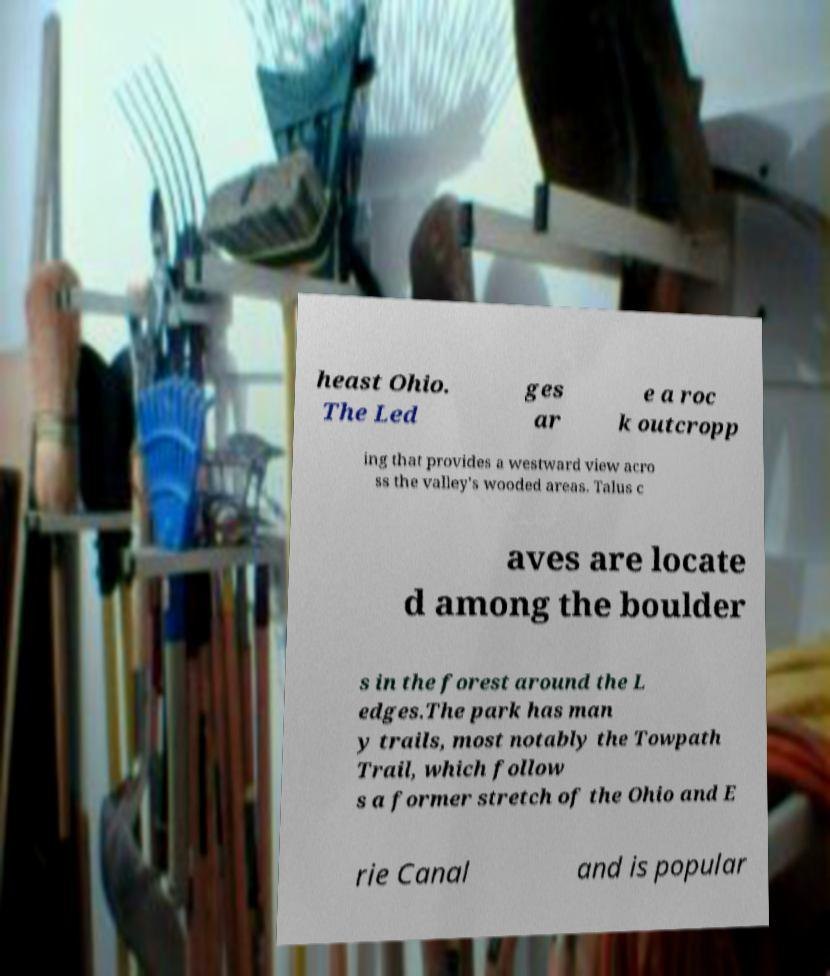Could you extract and type out the text from this image? heast Ohio. The Led ges ar e a roc k outcropp ing that provides a westward view acro ss the valley's wooded areas. Talus c aves are locate d among the boulder s in the forest around the L edges.The park has man y trails, most notably the Towpath Trail, which follow s a former stretch of the Ohio and E rie Canal and is popular 